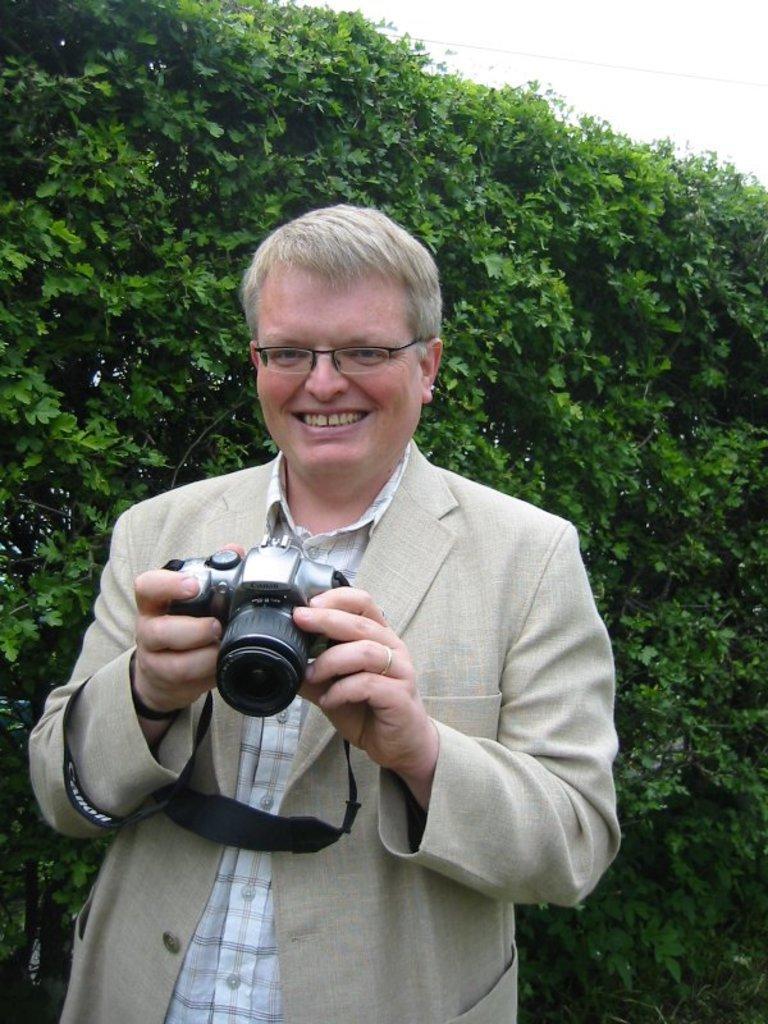How would you summarize this image in a sentence or two? As we can see in the image there is a sky, trees, a man standing over here. He is wearing cream color jacket, spectacles and holding a camera. 